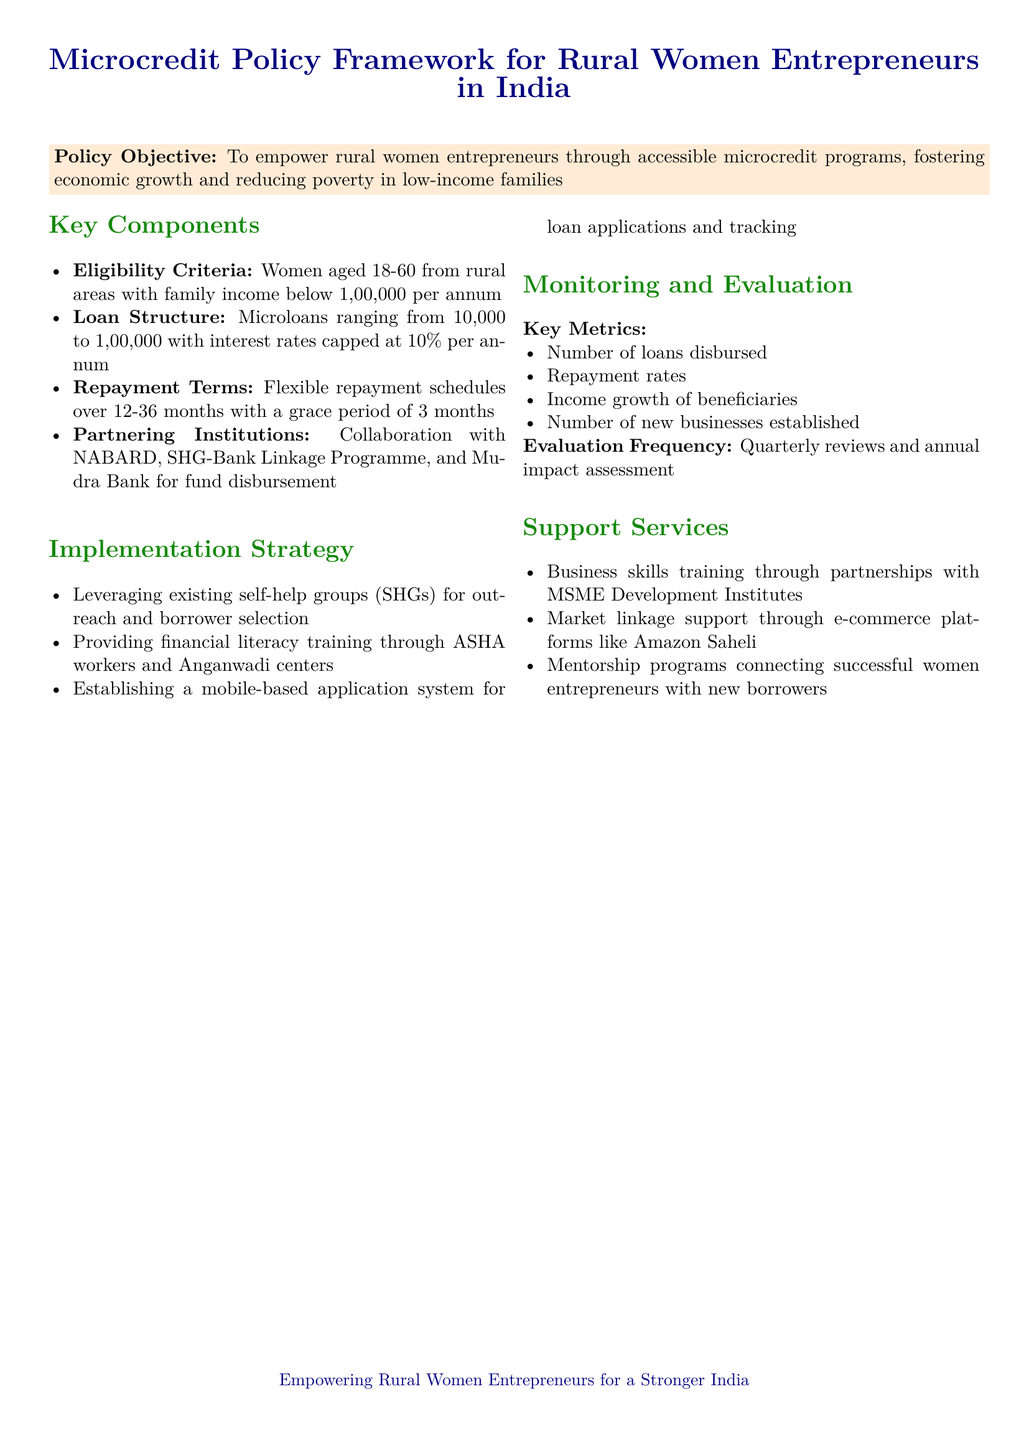What is the maximum loan amount available? The maximum loan amount available for microcredit programs is ₹1,00,000.
Answer: ₹1,00,000 What is the interest rate cap for the loans? The document states that the interest rates for the loans are capped at 10% per annum.
Answer: 10% Who are the target beneficiaries of the microcredit program? The document specifies that the target beneficiaries are women aged 18-60 from rural areas with a family income below ₹1,00,000 per annum.
Answer: Women aged 18-60 from rural areas What is the repayment period for the loans? The repayment terms are flexible over 12-36 months with a grace period of 3 months.
Answer: 12-36 months What institutions are mentioned for fundraising collaboration? The partnering institutions for fund disbursement include NABARD, SHG-Bank Linkage Programme, and Mudra Bank.
Answer: NABARD, SHG-Bank Linkage Programme, Mudra Bank How often will the impact assessment be conducted? The evaluation frequency for impact assessment is annual.
Answer: Annual What support services are provided to beneficiaries? The document mentions business skills training, market linkage support, and mentorship programs as support services.
Answer: Business skills training, market linkage support, mentorship programs What key metric is used to evaluate new businesses established? The number of new businesses established is one of the key metrics defined for monitoring and evaluation.
Answer: Number of new businesses established 